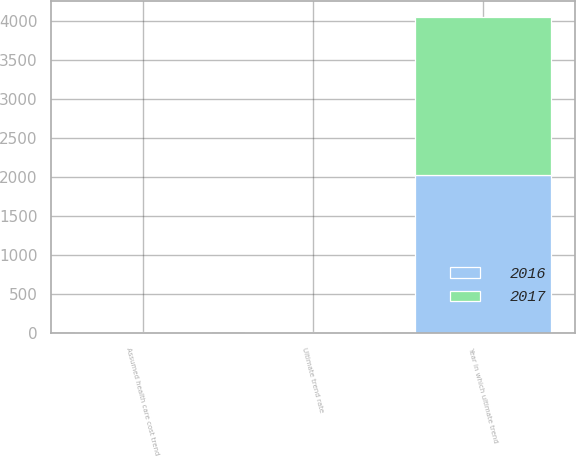Convert chart. <chart><loc_0><loc_0><loc_500><loc_500><stacked_bar_chart><ecel><fcel>Assumed health care cost trend<fcel>Ultimate trend rate<fcel>Year in which ultimate trend<nl><fcel>2017<fcel>7.5<fcel>5<fcel>2028<nl><fcel>2016<fcel>6.75<fcel>5<fcel>2024<nl></chart> 